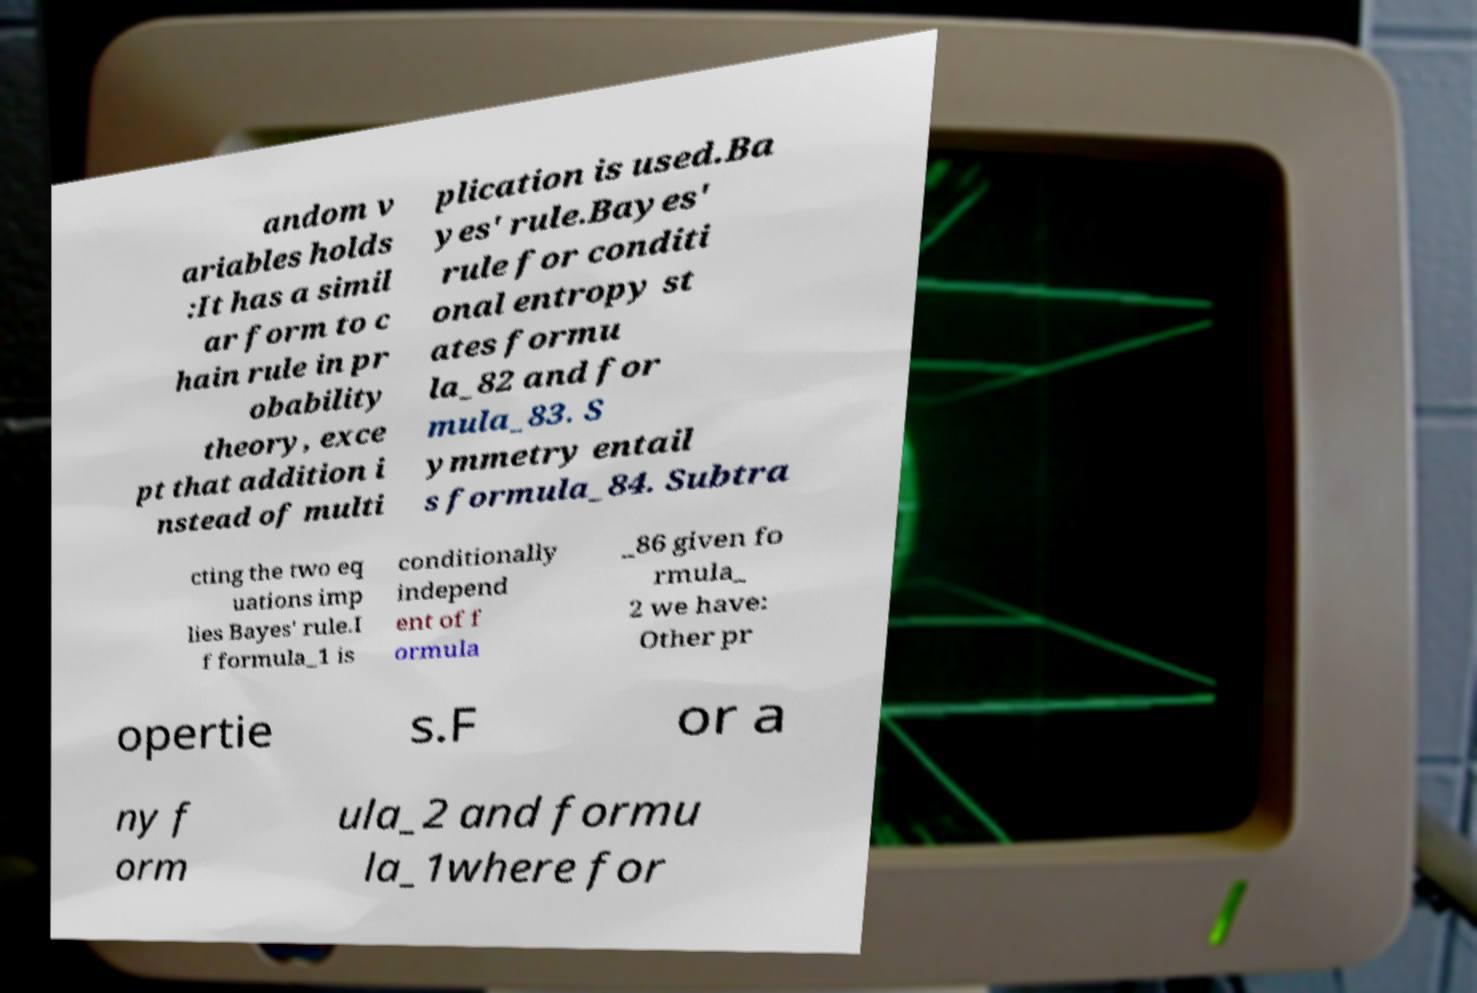For documentation purposes, I need the text within this image transcribed. Could you provide that? andom v ariables holds :It has a simil ar form to c hain rule in pr obability theory, exce pt that addition i nstead of multi plication is used.Ba yes' rule.Bayes' rule for conditi onal entropy st ates formu la_82 and for mula_83. S ymmetry entail s formula_84. Subtra cting the two eq uations imp lies Bayes' rule.I f formula_1 is conditionally independ ent of f ormula _86 given fo rmula_ 2 we have: Other pr opertie s.F or a ny f orm ula_2 and formu la_1where for 